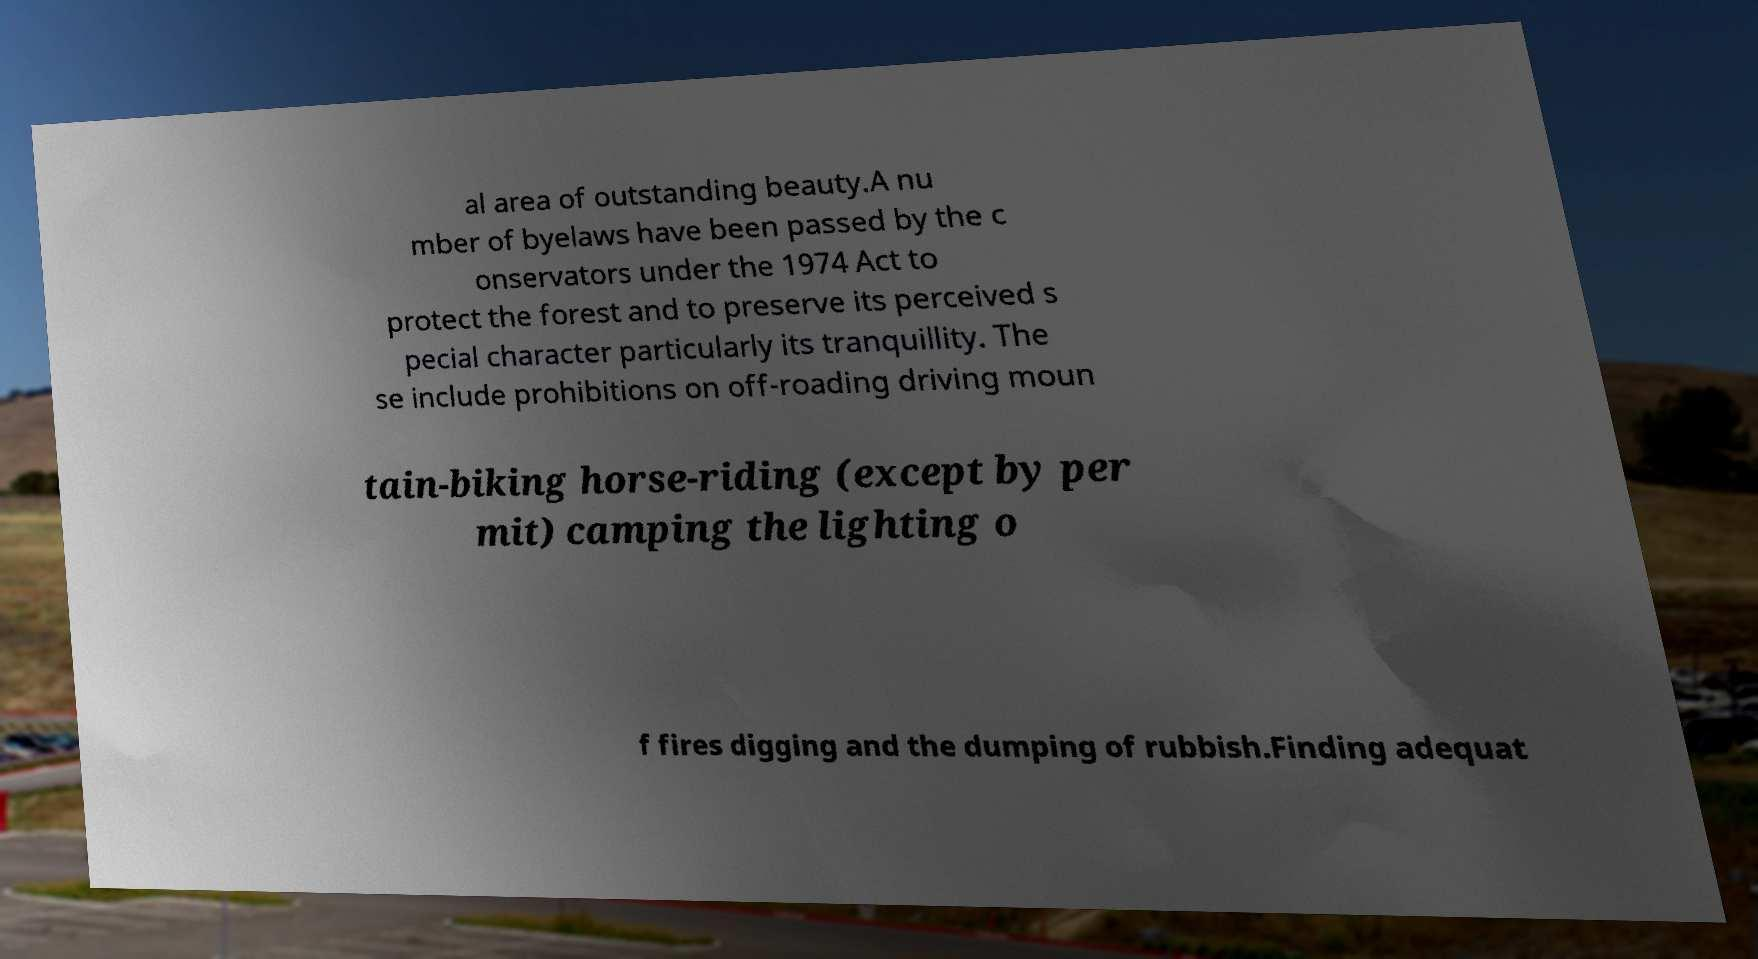I need the written content from this picture converted into text. Can you do that? al area of outstanding beauty.A nu mber of byelaws have been passed by the c onservators under the 1974 Act to protect the forest and to preserve its perceived s pecial character particularly its tranquillity. The se include prohibitions on off-roading driving moun tain-biking horse-riding (except by per mit) camping the lighting o f fires digging and the dumping of rubbish.Finding adequat 